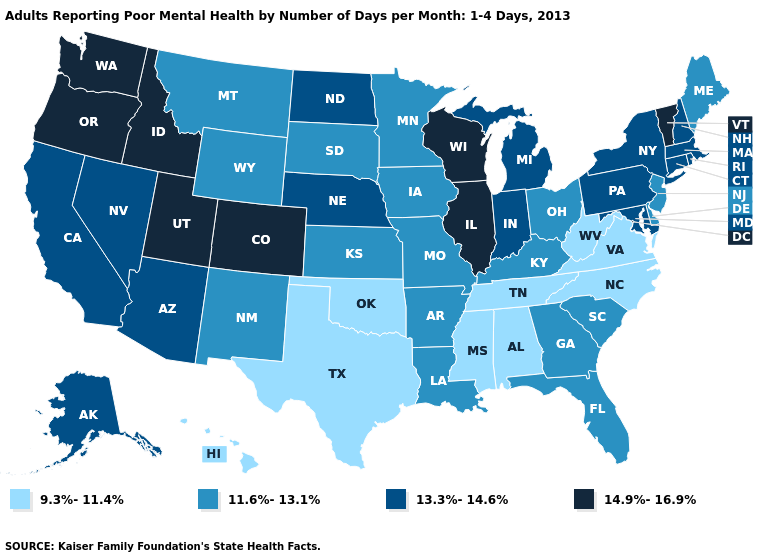What is the highest value in the MidWest ?
Quick response, please. 14.9%-16.9%. What is the value of Texas?
Keep it brief. 9.3%-11.4%. What is the value of Nebraska?
Give a very brief answer. 13.3%-14.6%. What is the highest value in states that border Louisiana?
Write a very short answer. 11.6%-13.1%. What is the value of California?
Be succinct. 13.3%-14.6%. Is the legend a continuous bar?
Answer briefly. No. Does Alabama have the lowest value in the USA?
Concise answer only. Yes. Does Ohio have a higher value than Maryland?
Give a very brief answer. No. What is the value of Virginia?
Answer briefly. 9.3%-11.4%. Which states have the lowest value in the Northeast?
Answer briefly. Maine, New Jersey. What is the highest value in the Northeast ?
Write a very short answer. 14.9%-16.9%. What is the highest value in the South ?
Write a very short answer. 13.3%-14.6%. Name the states that have a value in the range 13.3%-14.6%?
Quick response, please. Alaska, Arizona, California, Connecticut, Indiana, Maryland, Massachusetts, Michigan, Nebraska, Nevada, New Hampshire, New York, North Dakota, Pennsylvania, Rhode Island. Does Washington have the highest value in the USA?
Write a very short answer. Yes. Name the states that have a value in the range 9.3%-11.4%?
Quick response, please. Alabama, Hawaii, Mississippi, North Carolina, Oklahoma, Tennessee, Texas, Virginia, West Virginia. 